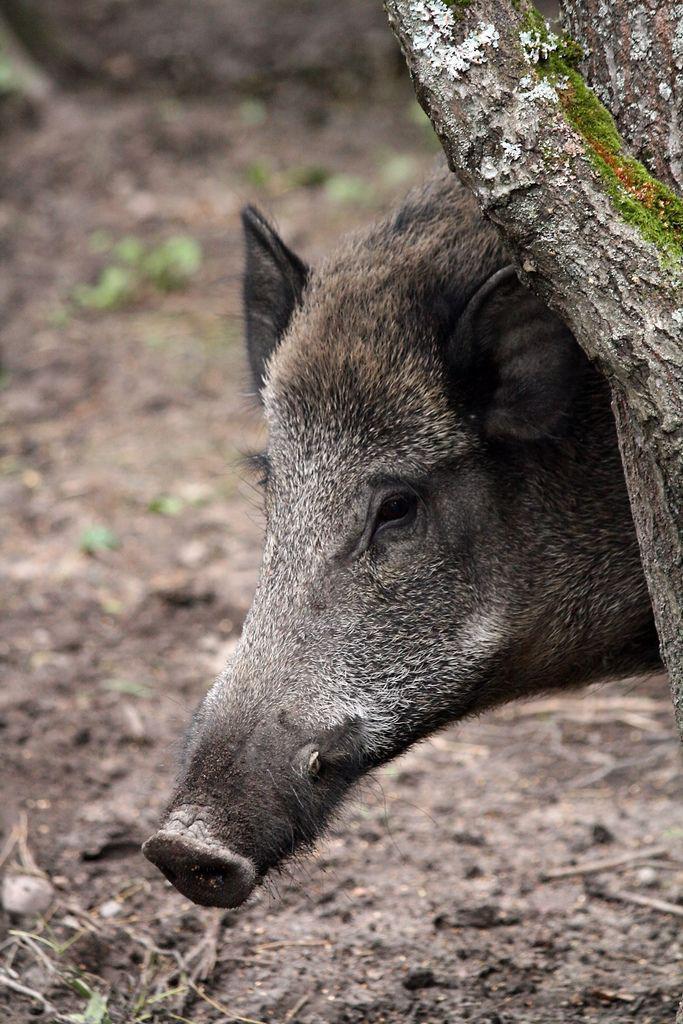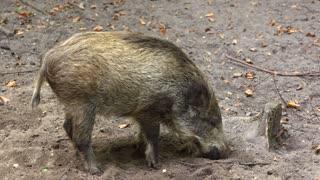The first image is the image on the left, the second image is the image on the right. For the images shown, is this caption "There are no more than 2 wild pigs." true? Answer yes or no. Yes. The first image is the image on the left, the second image is the image on the right. For the images displayed, is the sentence "there are two warthogs in the image pair" factually correct? Answer yes or no. Yes. 